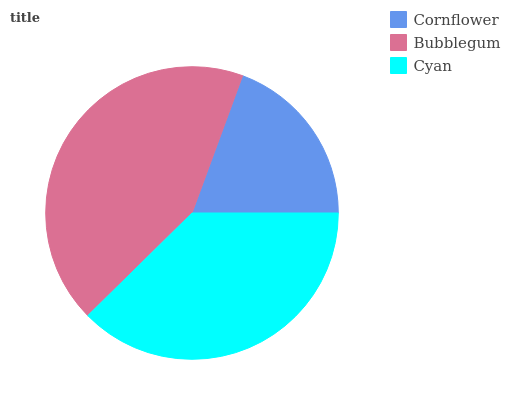Is Cornflower the minimum?
Answer yes or no. Yes. Is Bubblegum the maximum?
Answer yes or no. Yes. Is Cyan the minimum?
Answer yes or no. No. Is Cyan the maximum?
Answer yes or no. No. Is Bubblegum greater than Cyan?
Answer yes or no. Yes. Is Cyan less than Bubblegum?
Answer yes or no. Yes. Is Cyan greater than Bubblegum?
Answer yes or no. No. Is Bubblegum less than Cyan?
Answer yes or no. No. Is Cyan the high median?
Answer yes or no. Yes. Is Cyan the low median?
Answer yes or no. Yes. Is Cornflower the high median?
Answer yes or no. No. Is Cornflower the low median?
Answer yes or no. No. 